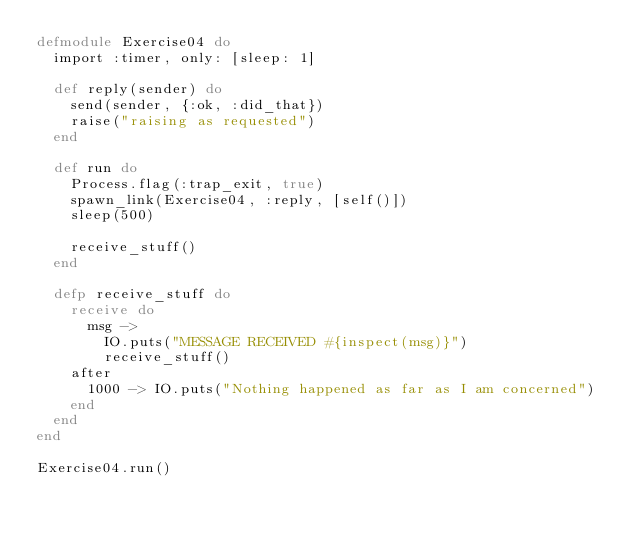Convert code to text. <code><loc_0><loc_0><loc_500><loc_500><_Elixir_>defmodule Exercise04 do
  import :timer, only: [sleep: 1]

  def reply(sender) do
    send(sender, {:ok, :did_that})
    raise("raising as requested")
  end

  def run do
    Process.flag(:trap_exit, true)
    spawn_link(Exercise04, :reply, [self()])
    sleep(500)

    receive_stuff()
  end

  defp receive_stuff do
    receive do
      msg ->
        IO.puts("MESSAGE RECEIVED #{inspect(msg)}")
        receive_stuff()
    after
      1000 -> IO.puts("Nothing happened as far as I am concerned")
    end
  end
end

Exercise04.run()
</code> 